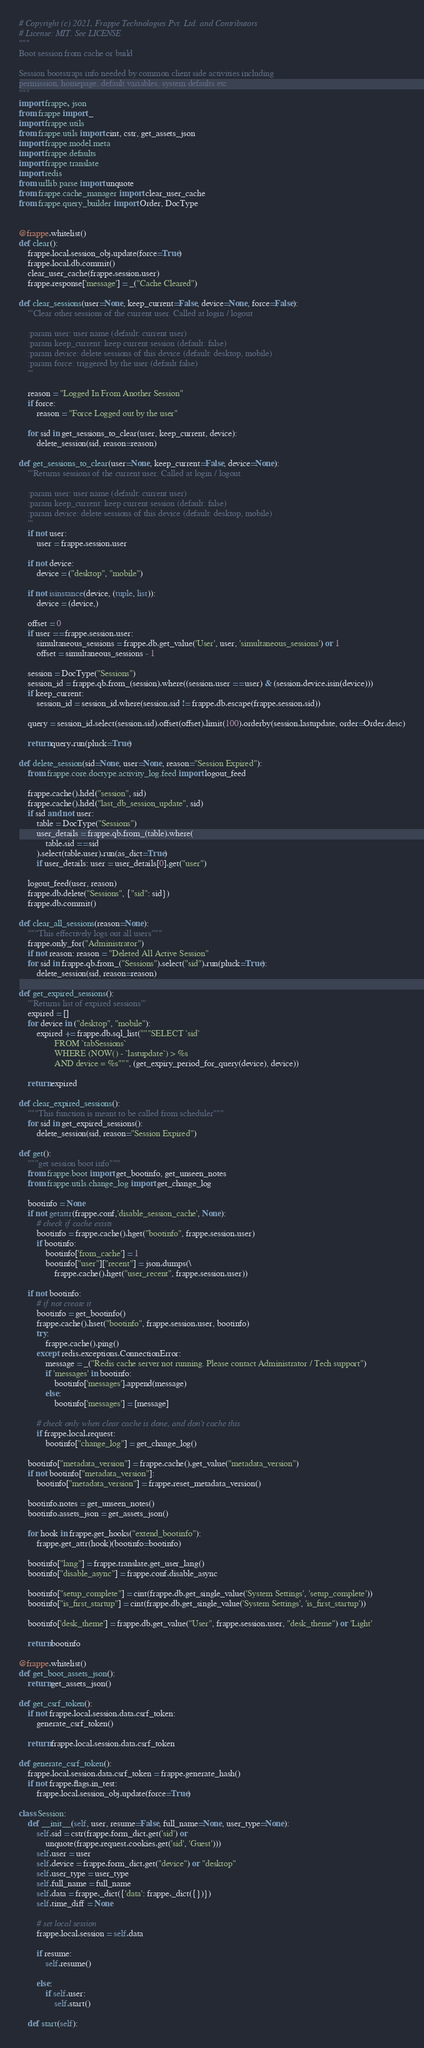Convert code to text. <code><loc_0><loc_0><loc_500><loc_500><_Python_># Copyright (c) 2021, Frappe Technologies Pvt. Ltd. and Contributors
# License: MIT. See LICENSE
"""
Boot session from cache or build

Session bootstraps info needed by common client side activities including
permission, homepage, default variables, system defaults etc
"""
import frappe, json
from frappe import _
import frappe.utils
from frappe.utils import cint, cstr, get_assets_json
import frappe.model.meta
import frappe.defaults
import frappe.translate
import redis
from urllib.parse import unquote
from frappe.cache_manager import clear_user_cache
from frappe.query_builder import Order, DocType


@frappe.whitelist()
def clear():
	frappe.local.session_obj.update(force=True)
	frappe.local.db.commit()
	clear_user_cache(frappe.session.user)
	frappe.response['message'] = _("Cache Cleared")

def clear_sessions(user=None, keep_current=False, device=None, force=False):
	'''Clear other sessions of the current user. Called at login / logout

	:param user: user name (default: current user)
	:param keep_current: keep current session (default: false)
	:param device: delete sessions of this device (default: desktop, mobile)
	:param force: triggered by the user (default false)
	'''

	reason = "Logged In From Another Session"
	if force:
		reason = "Force Logged out by the user"

	for sid in get_sessions_to_clear(user, keep_current, device):
		delete_session(sid, reason=reason)

def get_sessions_to_clear(user=None, keep_current=False, device=None):
	'''Returns sessions of the current user. Called at login / logout

	:param user: user name (default: current user)
	:param keep_current: keep current session (default: false)
	:param device: delete sessions of this device (default: desktop, mobile)
	'''
	if not user:
		user = frappe.session.user

	if not device:
		device = ("desktop", "mobile")

	if not isinstance(device, (tuple, list)):
		device = (device,)

	offset = 0
	if user == frappe.session.user:
		simultaneous_sessions = frappe.db.get_value('User', user, 'simultaneous_sessions') or 1
		offset = simultaneous_sessions - 1

	session = DocType("Sessions")
	session_id = frappe.qb.from_(session).where((session.user == user) & (session.device.isin(device)))
	if keep_current:
		session_id = session_id.where(session.sid != frappe.db.escape(frappe.session.sid))

	query = session_id.select(session.sid).offset(offset).limit(100).orderby(session.lastupdate, order=Order.desc)

	return query.run(pluck=True)

def delete_session(sid=None, user=None, reason="Session Expired"):
	from frappe.core.doctype.activity_log.feed import logout_feed

	frappe.cache().hdel("session", sid)
	frappe.cache().hdel("last_db_session_update", sid)
	if sid and not user:
		table = DocType("Sessions")
		user_details = frappe.qb.from_(table).where(
			table.sid == sid
		).select(table.user).run(as_dict=True)
		if user_details: user = user_details[0].get("user")

	logout_feed(user, reason)
	frappe.db.delete("Sessions", {"sid": sid})
	frappe.db.commit()

def clear_all_sessions(reason=None):
	"""This effectively logs out all users"""
	frappe.only_for("Administrator")
	if not reason: reason = "Deleted All Active Session"
	for sid in frappe.qb.from_("Sessions").select("sid").run(pluck=True):
		delete_session(sid, reason=reason)

def get_expired_sessions():
	'''Returns list of expired sessions'''
	expired = []
	for device in ("desktop", "mobile"):
		expired += frappe.db.sql_list("""SELECT `sid`
				FROM `tabSessions`
				WHERE (NOW() - `lastupdate`) > %s
				AND device = %s""", (get_expiry_period_for_query(device), device))

	return expired

def clear_expired_sessions():
	"""This function is meant to be called from scheduler"""
	for sid in get_expired_sessions():
		delete_session(sid, reason="Session Expired")

def get():
	"""get session boot info"""
	from frappe.boot import get_bootinfo, get_unseen_notes
	from frappe.utils.change_log import get_change_log

	bootinfo = None
	if not getattr(frappe.conf,'disable_session_cache', None):
		# check if cache exists
		bootinfo = frappe.cache().hget("bootinfo", frappe.session.user)
		if bootinfo:
			bootinfo['from_cache'] = 1
			bootinfo["user"]["recent"] = json.dumps(\
				frappe.cache().hget("user_recent", frappe.session.user))

	if not bootinfo:
		# if not create it
		bootinfo = get_bootinfo()
		frappe.cache().hset("bootinfo", frappe.session.user, bootinfo)
		try:
			frappe.cache().ping()
		except redis.exceptions.ConnectionError:
			message = _("Redis cache server not running. Please contact Administrator / Tech support")
			if 'messages' in bootinfo:
				bootinfo['messages'].append(message)
			else:
				bootinfo['messages'] = [message]

		# check only when clear cache is done, and don't cache this
		if frappe.local.request:
			bootinfo["change_log"] = get_change_log()

	bootinfo["metadata_version"] = frappe.cache().get_value("metadata_version")
	if not bootinfo["metadata_version"]:
		bootinfo["metadata_version"] = frappe.reset_metadata_version()

	bootinfo.notes = get_unseen_notes()
	bootinfo.assets_json = get_assets_json()

	for hook in frappe.get_hooks("extend_bootinfo"):
		frappe.get_attr(hook)(bootinfo=bootinfo)

	bootinfo["lang"] = frappe.translate.get_user_lang()
	bootinfo["disable_async"] = frappe.conf.disable_async

	bootinfo["setup_complete"] = cint(frappe.db.get_single_value('System Settings', 'setup_complete'))
	bootinfo["is_first_startup"] = cint(frappe.db.get_single_value('System Settings', 'is_first_startup'))

	bootinfo['desk_theme'] = frappe.db.get_value("User", frappe.session.user, "desk_theme") or 'Light'

	return bootinfo

@frappe.whitelist()
def get_boot_assets_json():
	return get_assets_json()

def get_csrf_token():
	if not frappe.local.session.data.csrf_token:
		generate_csrf_token()

	return frappe.local.session.data.csrf_token

def generate_csrf_token():
	frappe.local.session.data.csrf_token = frappe.generate_hash()
	if not frappe.flags.in_test:
		frappe.local.session_obj.update(force=True)

class Session:
	def __init__(self, user, resume=False, full_name=None, user_type=None):
		self.sid = cstr(frappe.form_dict.get('sid') or
			unquote(frappe.request.cookies.get('sid', 'Guest')))
		self.user = user
		self.device = frappe.form_dict.get("device") or "desktop"
		self.user_type = user_type
		self.full_name = full_name
		self.data = frappe._dict({'data': frappe._dict({})})
		self.time_diff = None

		# set local session
		frappe.local.session = self.data

		if resume:
			self.resume()

		else:
			if self.user:
				self.start()

	def start(self):</code> 